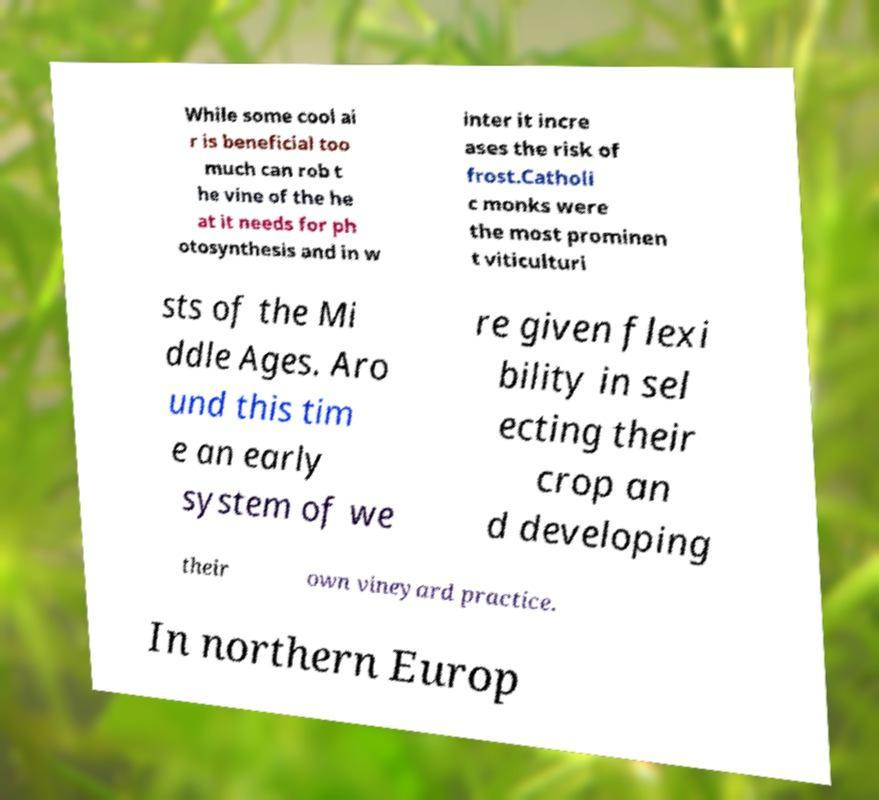Please identify and transcribe the text found in this image. While some cool ai r is beneficial too much can rob t he vine of the he at it needs for ph otosynthesis and in w inter it incre ases the risk of frost.Catholi c monks were the most prominen t viticulturi sts of the Mi ddle Ages. Aro und this tim e an early system of we re given flexi bility in sel ecting their crop an d developing their own vineyard practice. In northern Europ 